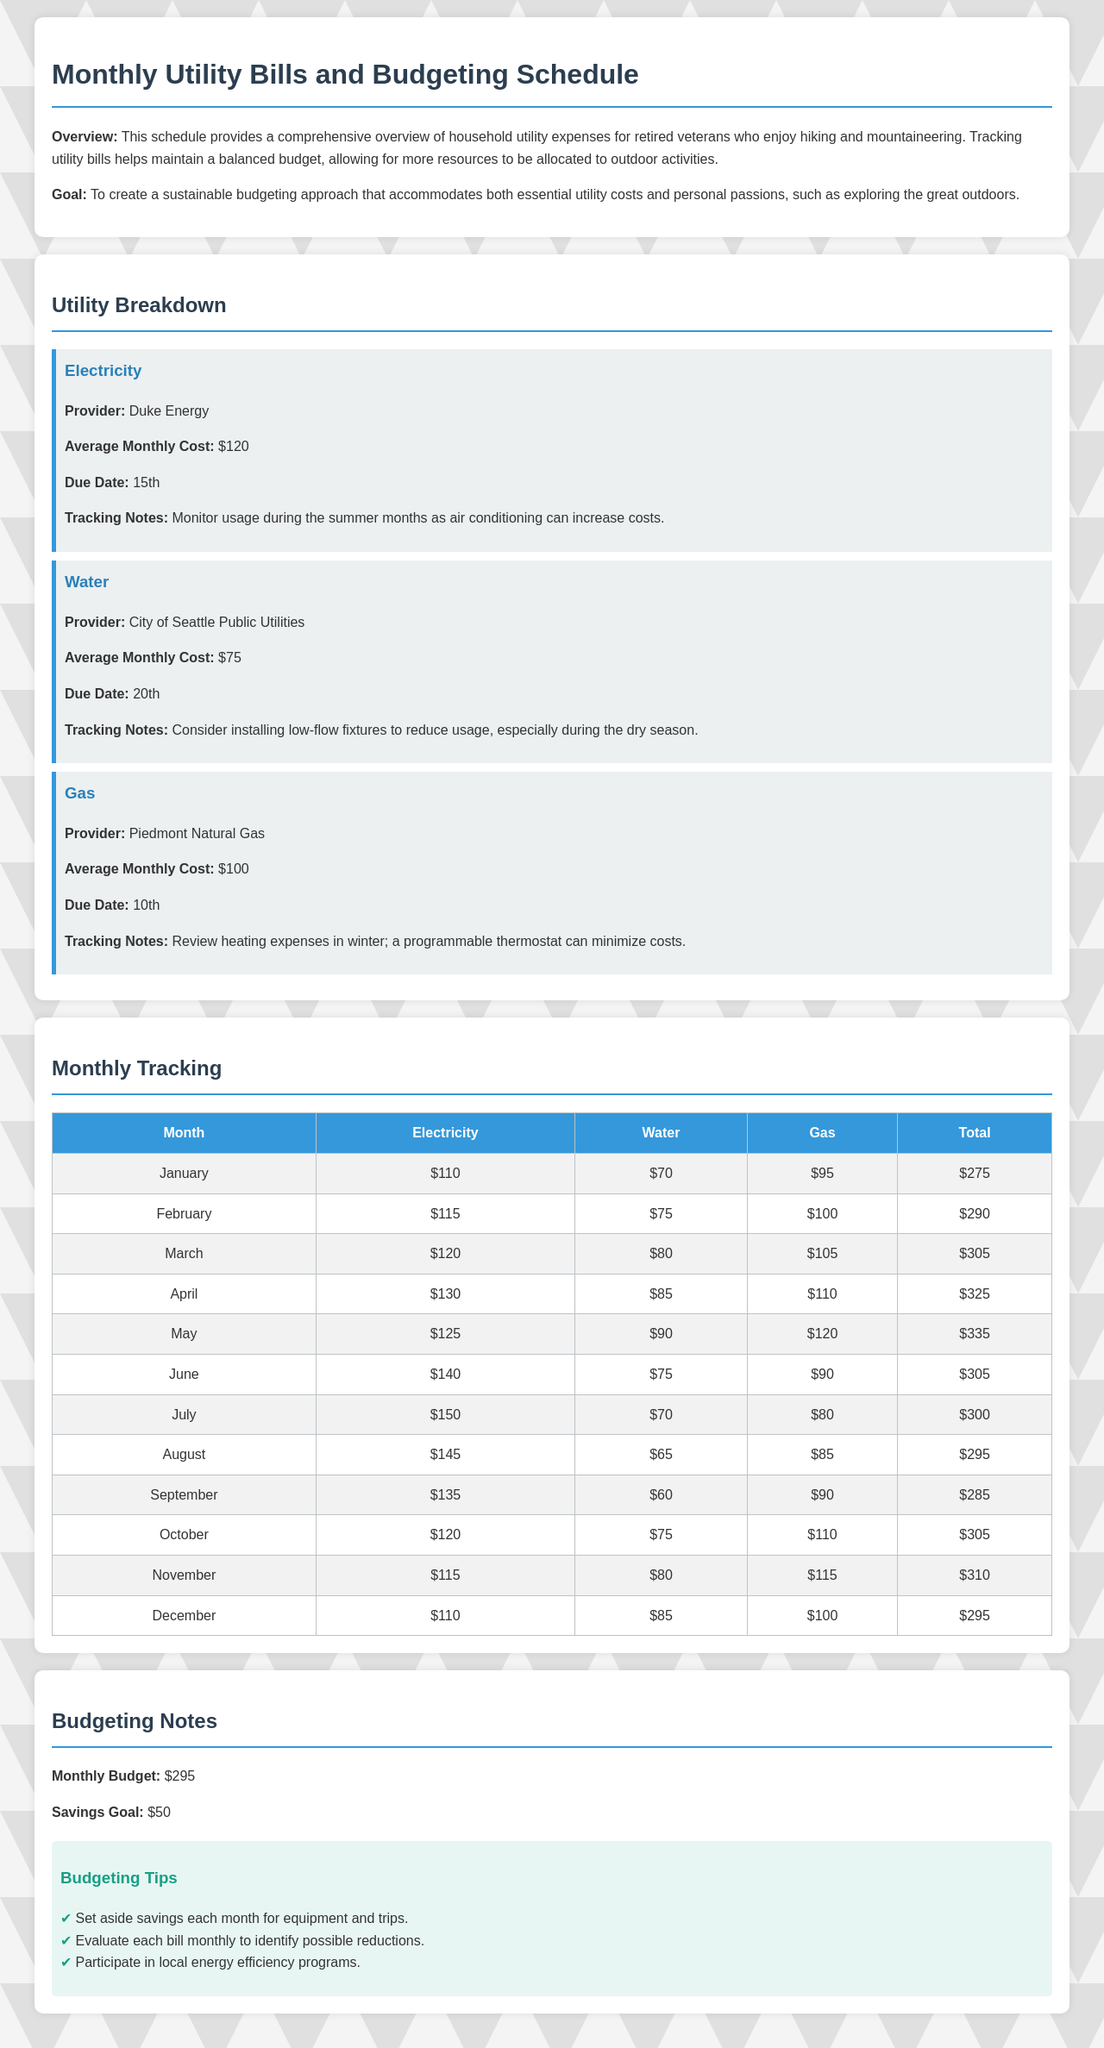What is the average monthly cost for electricity? The average monthly cost for electricity is explicitly stated in the document as $120.
Answer: $120 What is the due date for the gas bill? The due date for the gas bill is mentioned as the 10th in the document.
Answer: 10th Which provider supplies water? The document specifies "City of Seattle Public Utilities" as the water provider.
Answer: City of Seattle Public Utilities What is the total monthly budget? The total monthly budget is outlined in the budgeting notes and is $295.
Answer: $295 In which month do utility costs peak? By reviewing the monthly tracking table, April shows the highest total at $325.
Answer: April What is the savings goal each month? The savings goal is indicated in the budgeting notes as $50.
Answer: $50 How much did electricity cost in July? The table indicates that the electricity cost for July is $150.
Answer: $150 Which month has the lowest water cost? From the monthly tracking table, September shows the lowest water cost at $60.
Answer: September What is the main purpose of this schedule? The overview mentions that the purpose is to create a sustainable budgeting approach for utility costs.
Answer: Sustainable budgeting approach 